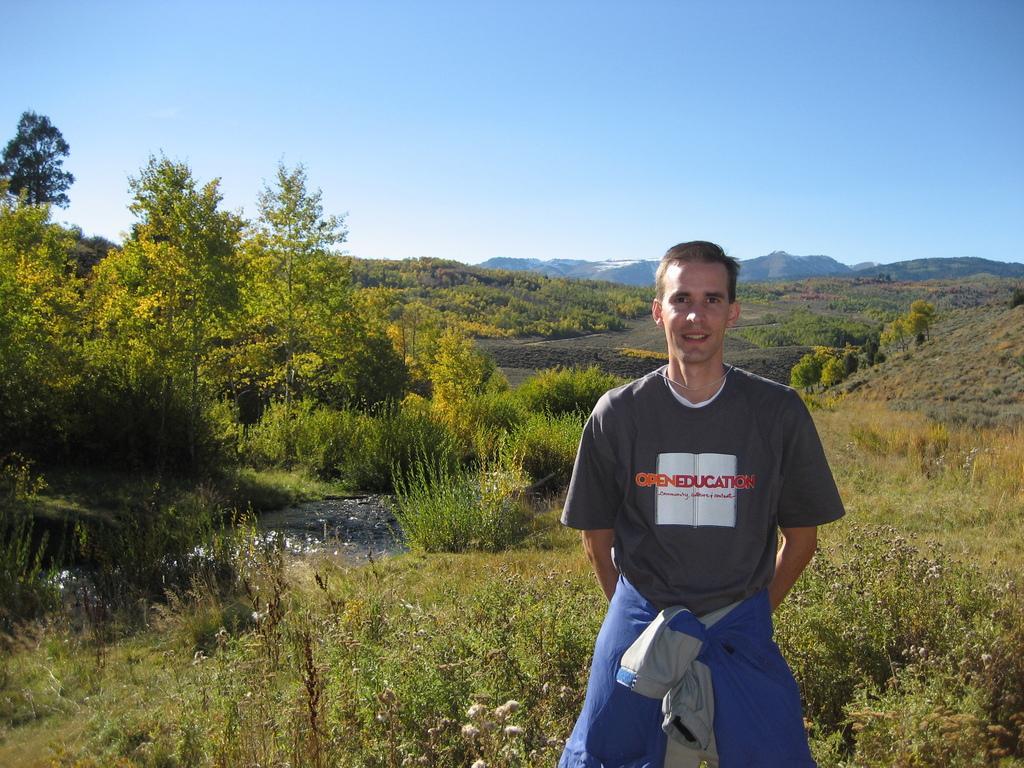In one or two sentences, can you explain what this image depicts? In this picture we can see a man standing, at the bottom there is grass, we can see trees in the background, there is the sky at the top of the picture. 